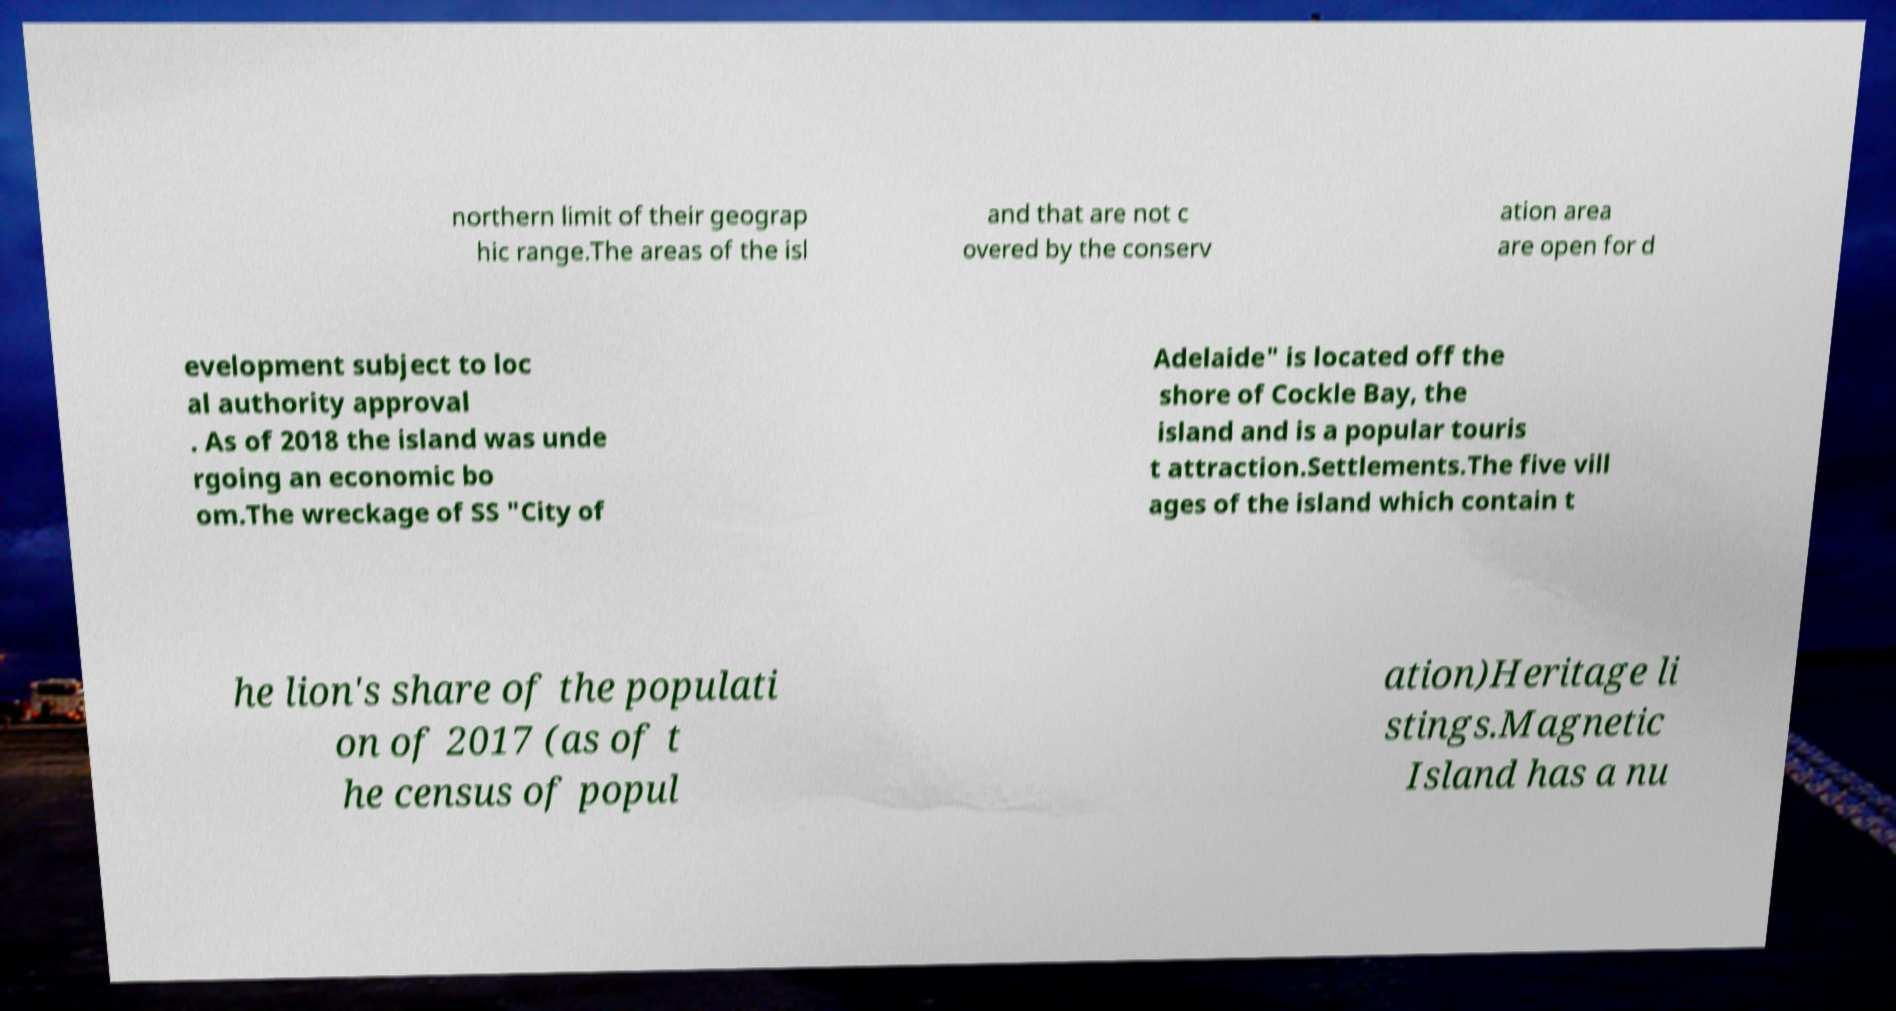Could you assist in decoding the text presented in this image and type it out clearly? northern limit of their geograp hic range.The areas of the isl and that are not c overed by the conserv ation area are open for d evelopment subject to loc al authority approval . As of 2018 the island was unde rgoing an economic bo om.The wreckage of SS "City of Adelaide" is located off the shore of Cockle Bay, the island and is a popular touris t attraction.Settlements.The five vill ages of the island which contain t he lion's share of the populati on of 2017 (as of t he census of popul ation)Heritage li stings.Magnetic Island has a nu 